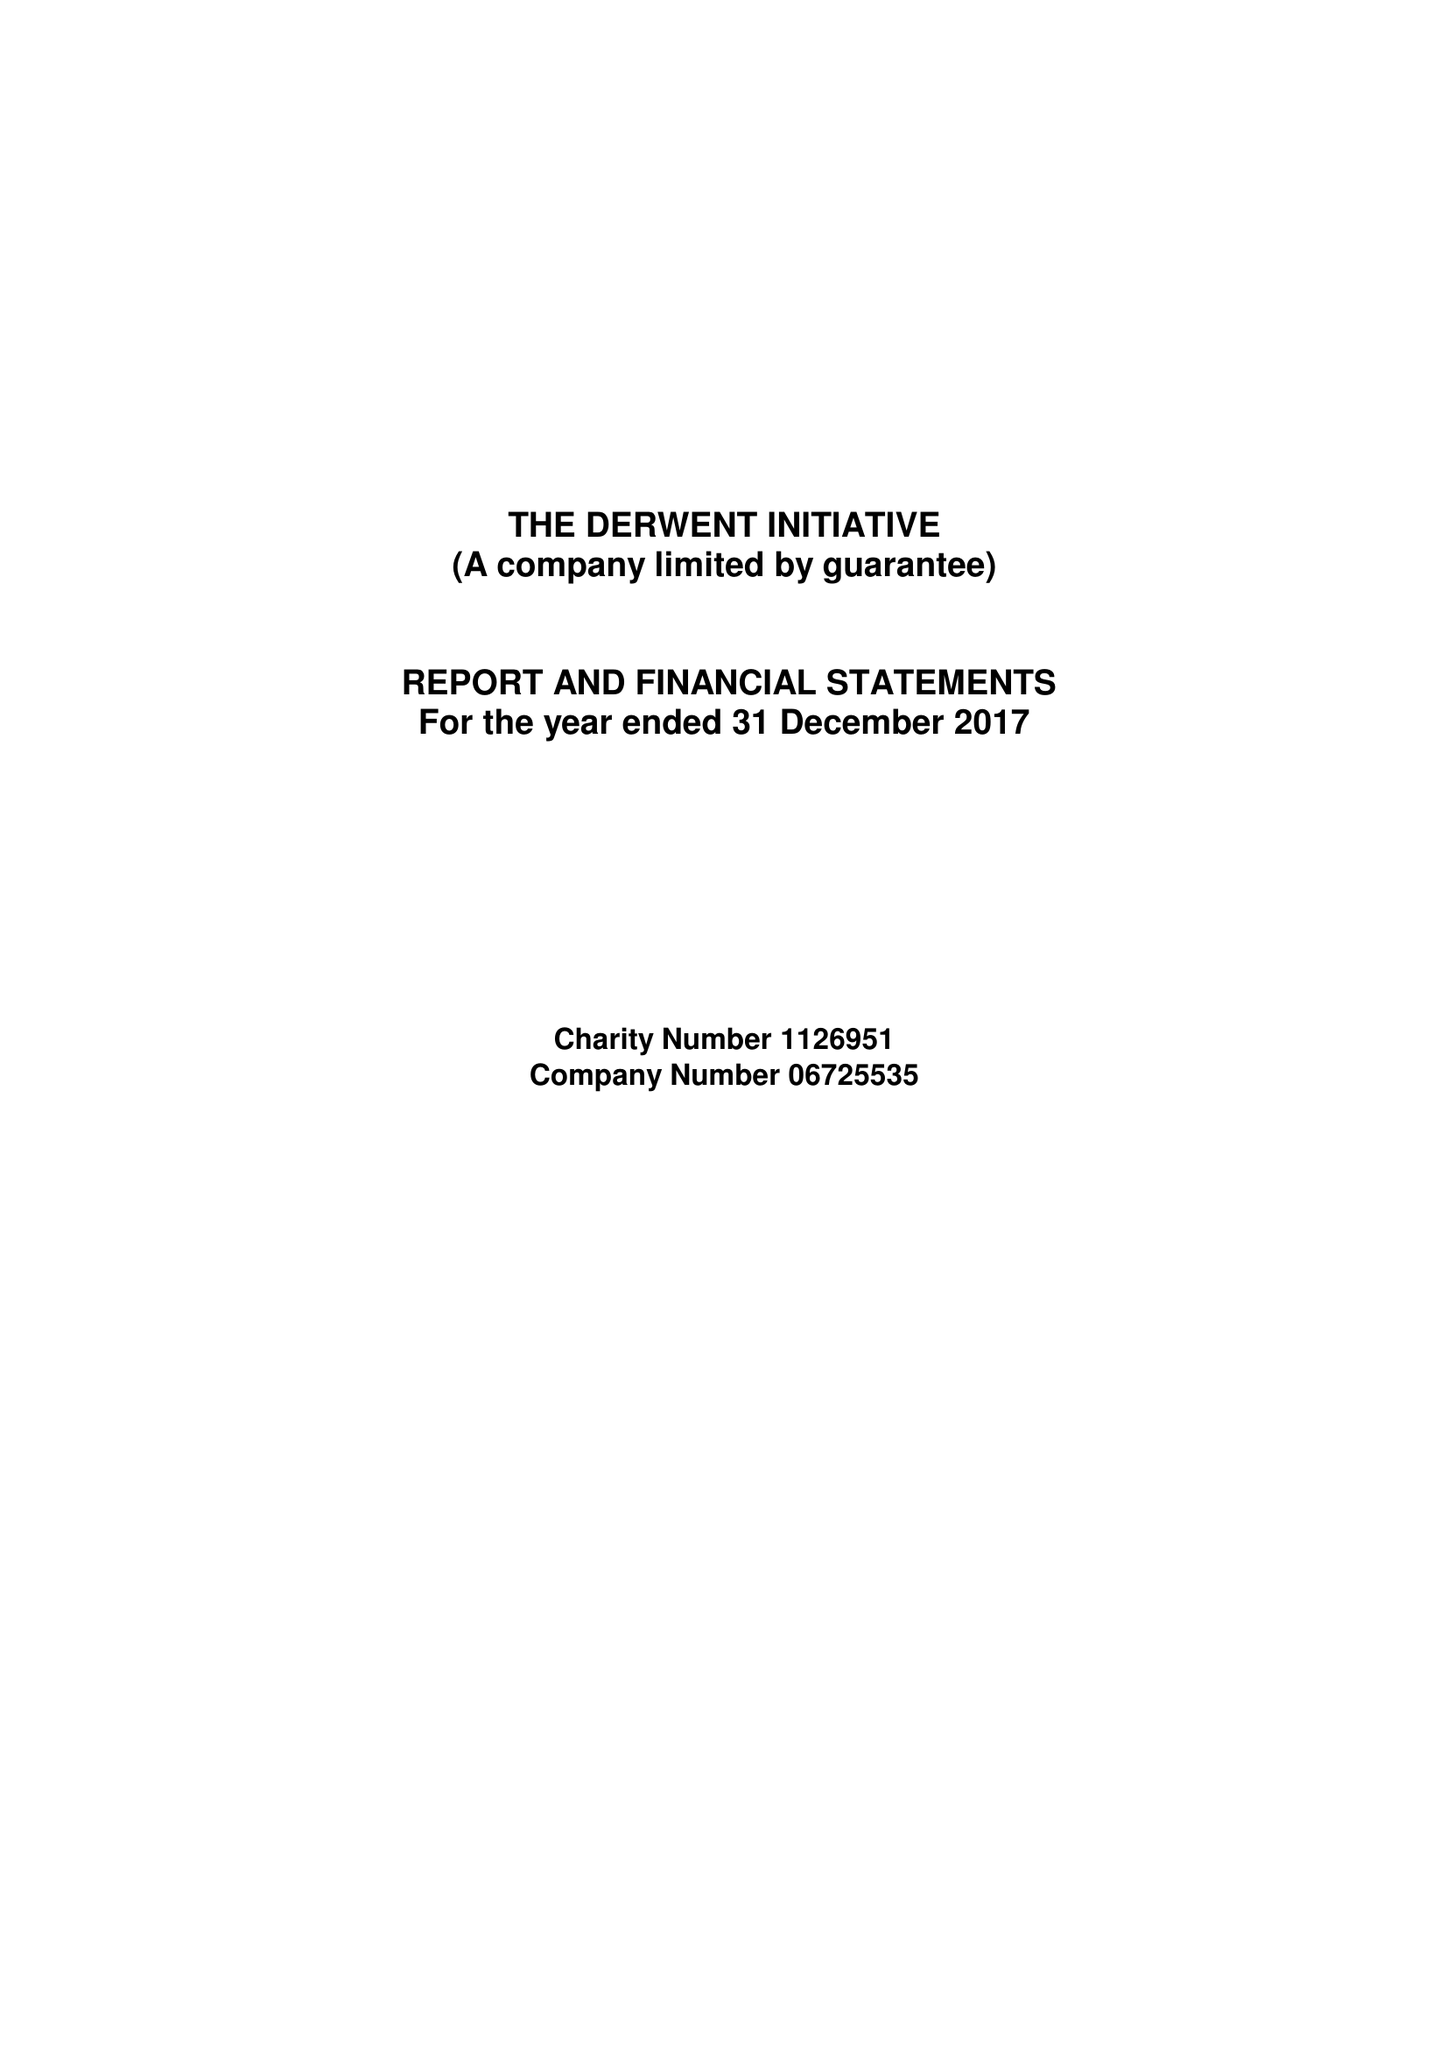What is the value for the charity_number?
Answer the question using a single word or phrase. 1126951 